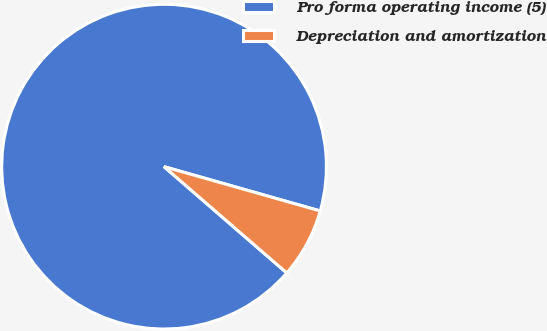<chart> <loc_0><loc_0><loc_500><loc_500><pie_chart><fcel>Pro forma operating income (5)<fcel>Depreciation and amortization<nl><fcel>93.04%<fcel>6.96%<nl></chart> 